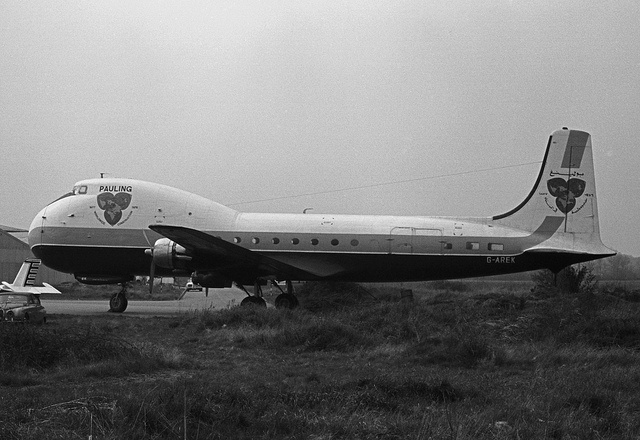Describe the objects in this image and their specific colors. I can see airplane in lightgray, black, darkgray, and gray tones and airplane in lightgray, gray, black, and darkgray tones in this image. 